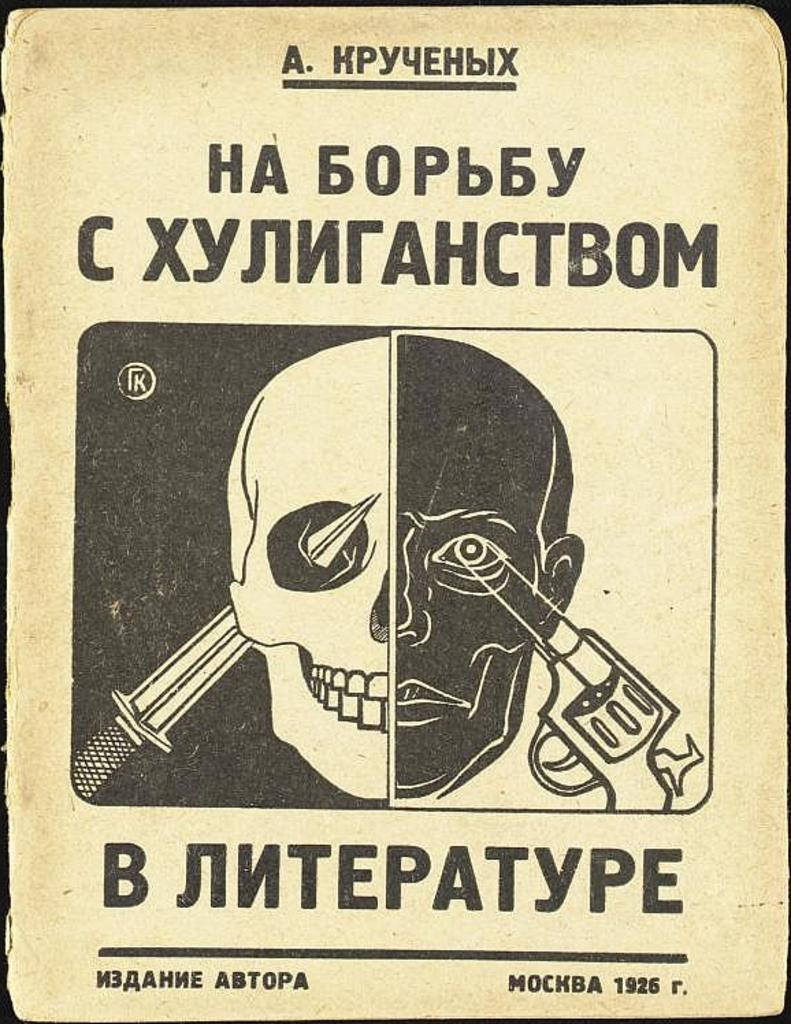What color is the poster paper in the image? The poster paper is white in color. What image is featured on the poster? There is a skull printed on the poster. Is there any text on the poster besides the image? Yes, there is a small quote at the top of the poster. Can you tell me how many ears are visible on the skull in the image? There are no ears visible on the skull in the image, as skulls do not have ears. What type of disease is mentioned in the small quote at the top of the poster? There is no mention of any disease in the small quote at the top of the poster. 